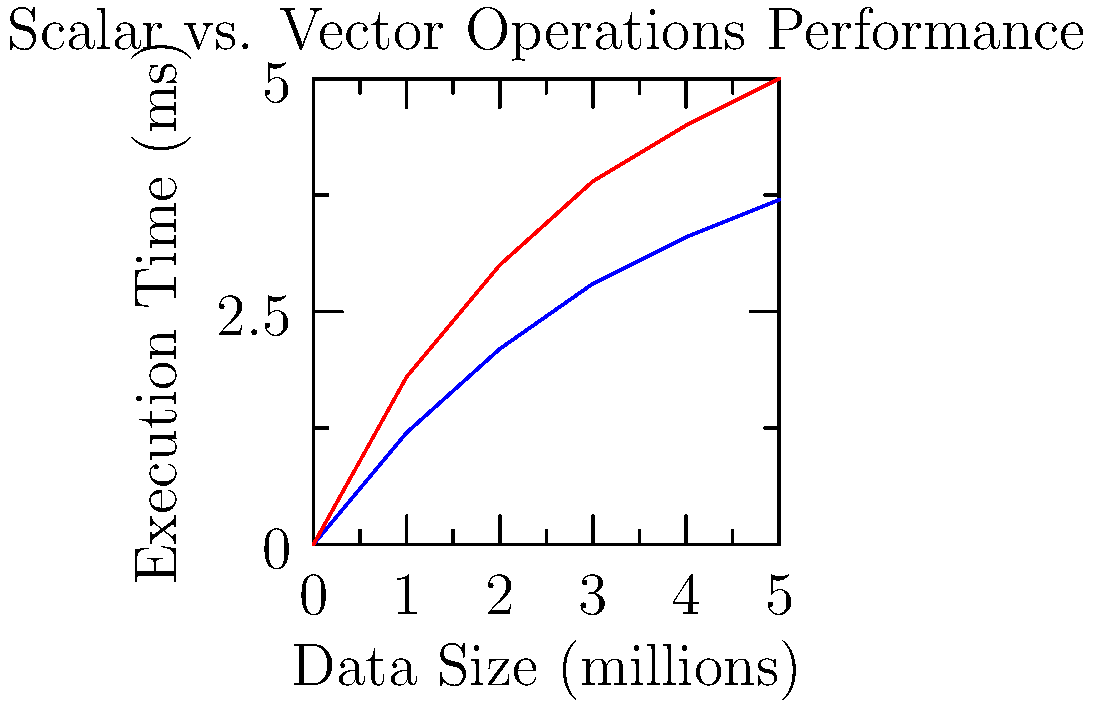Based on the graph, which shows the execution time for scalar and vector operations on different data sizes, what is the approximate percentage improvement in execution time when using vector operations instead of scalar operations for a data size of 5 million elements? To calculate the percentage improvement in execution time, we need to follow these steps:

1. Identify the execution times for scalar and vector operations at 5 million data size:
   Scalar operations (blue line): $\approx 3.7$ ms
   Vector operations (red line): $\approx 5.0$ ms

2. Calculate the difference in execution time:
   $\text{Difference} = 5.0 - 3.7 = 1.3$ ms

3. Calculate the percentage improvement:
   $\text{Percentage Improvement} = \frac{\text{Difference}}{\text{Scalar Time}} \times 100\%$
   $= \frac{1.3}{3.7} \times 100\% \approx 35.14\%$

4. Round to the nearest whole percentage:
   $35.14\% \approx 35\%$

Therefore, the approximate percentage improvement in execution time when using vector operations instead of scalar operations for a data size of 5 million elements is 35%.
Answer: 35% 